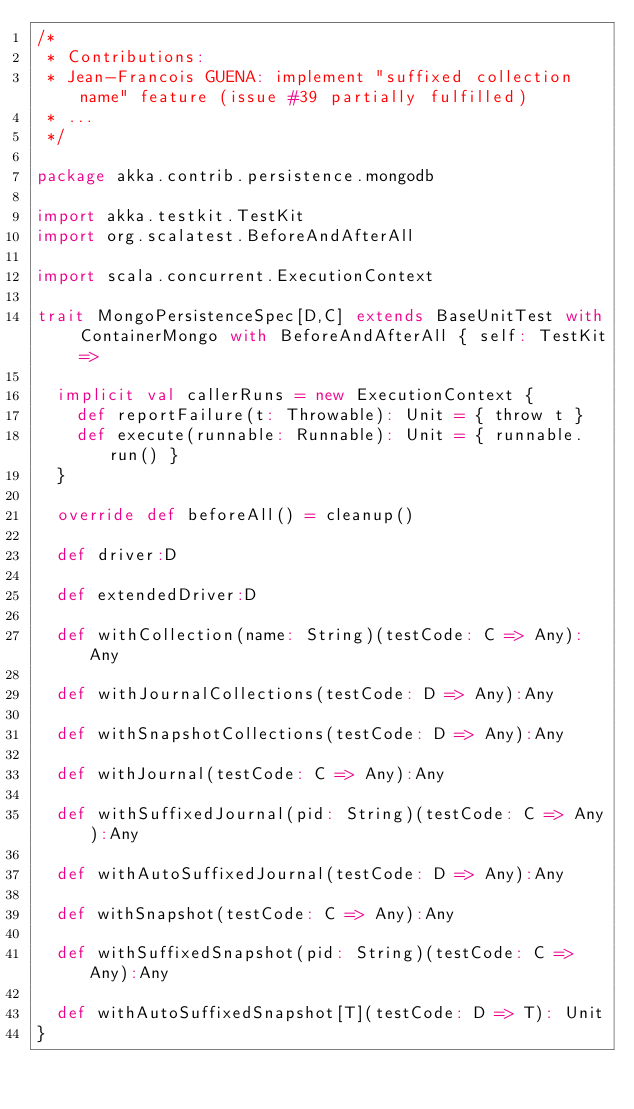<code> <loc_0><loc_0><loc_500><loc_500><_Scala_>/* 
 * Contributions:
 * Jean-Francois GUENA: implement "suffixed collection name" feature (issue #39 partially fulfilled)
 * ...
 */

package akka.contrib.persistence.mongodb

import akka.testkit.TestKit
import org.scalatest.BeforeAndAfterAll

import scala.concurrent.ExecutionContext

trait MongoPersistenceSpec[D,C] extends BaseUnitTest with ContainerMongo with BeforeAndAfterAll { self: TestKit =>

  implicit val callerRuns = new ExecutionContext {
    def reportFailure(t: Throwable): Unit = { throw t }
    def execute(runnable: Runnable): Unit = { runnable.run() }
  }

  override def beforeAll() = cleanup()

  def driver:D
  
  def extendedDriver:D

  def withCollection(name: String)(testCode: C => Any):Any
  
  def withJournalCollections(testCode: D => Any):Any
  
  def withSnapshotCollections(testCode: D => Any):Any

  def withJournal(testCode: C => Any):Any
  
  def withSuffixedJournal(pid: String)(testCode: C => Any):Any
  
  def withAutoSuffixedJournal(testCode: D => Any):Any

  def withSnapshot(testCode: C => Any):Any
  
  def withSuffixedSnapshot(pid: String)(testCode: C => Any):Any
  
  def withAutoSuffixedSnapshot[T](testCode: D => T): Unit
}
</code> 